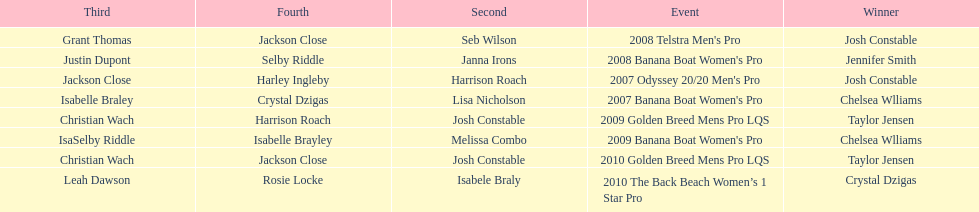In what event did chelsea williams win her first title? 2007 Banana Boat Women's Pro. 